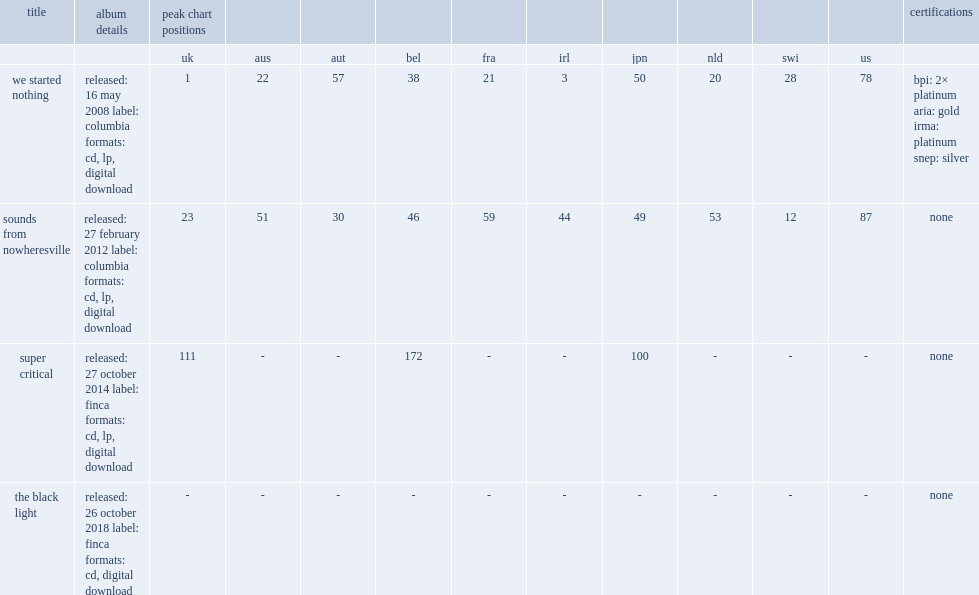What is the peak chart position for the ting tings third studio album, super critical on the uk chart? 111.0. 